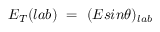Convert formula to latex. <formula><loc_0><loc_0><loc_500><loc_500>E _ { T } ( { l a b } ) \ = \ ( E \sin \theta ) _ { l a b }</formula> 